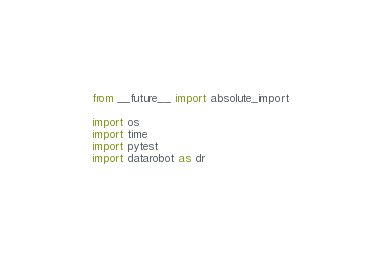Convert code to text. <code><loc_0><loc_0><loc_500><loc_500><_Python_>from __future__ import absolute_import

import os
import time
import pytest
import datarobot as dr
</code> 